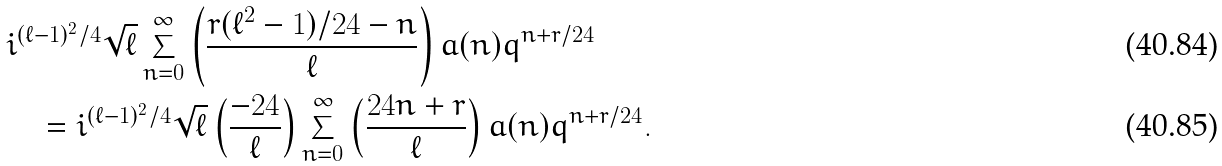Convert formula to latex. <formula><loc_0><loc_0><loc_500><loc_500>& i ^ { ( \ell - 1 ) ^ { 2 } / 4 } \sqrt { \ell } \sum _ { n = 0 } ^ { \infty } \left ( \frac { r ( \ell ^ { 2 } - 1 ) / 2 4 - n } \ell \right ) a ( n ) q ^ { n + r / 2 4 } \\ & \quad = i ^ { ( \ell - 1 ) ^ { 2 } / 4 } \sqrt { \ell } \left ( \frac { - 2 4 } \ell \right ) \sum _ { n = 0 } ^ { \infty } \left ( \frac { 2 4 n + r } \ell \right ) a ( n ) q ^ { n + r / 2 4 } .</formula> 